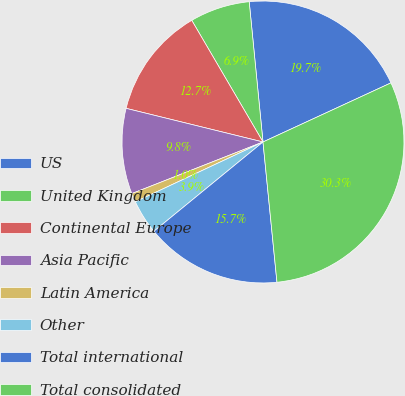<chart> <loc_0><loc_0><loc_500><loc_500><pie_chart><fcel>US<fcel>United Kingdom<fcel>Continental Europe<fcel>Asia Pacific<fcel>Latin America<fcel>Other<fcel>Total international<fcel>Total consolidated<nl><fcel>19.67%<fcel>6.87%<fcel>12.73%<fcel>9.8%<fcel>1.01%<fcel>3.94%<fcel>15.66%<fcel>30.3%<nl></chart> 